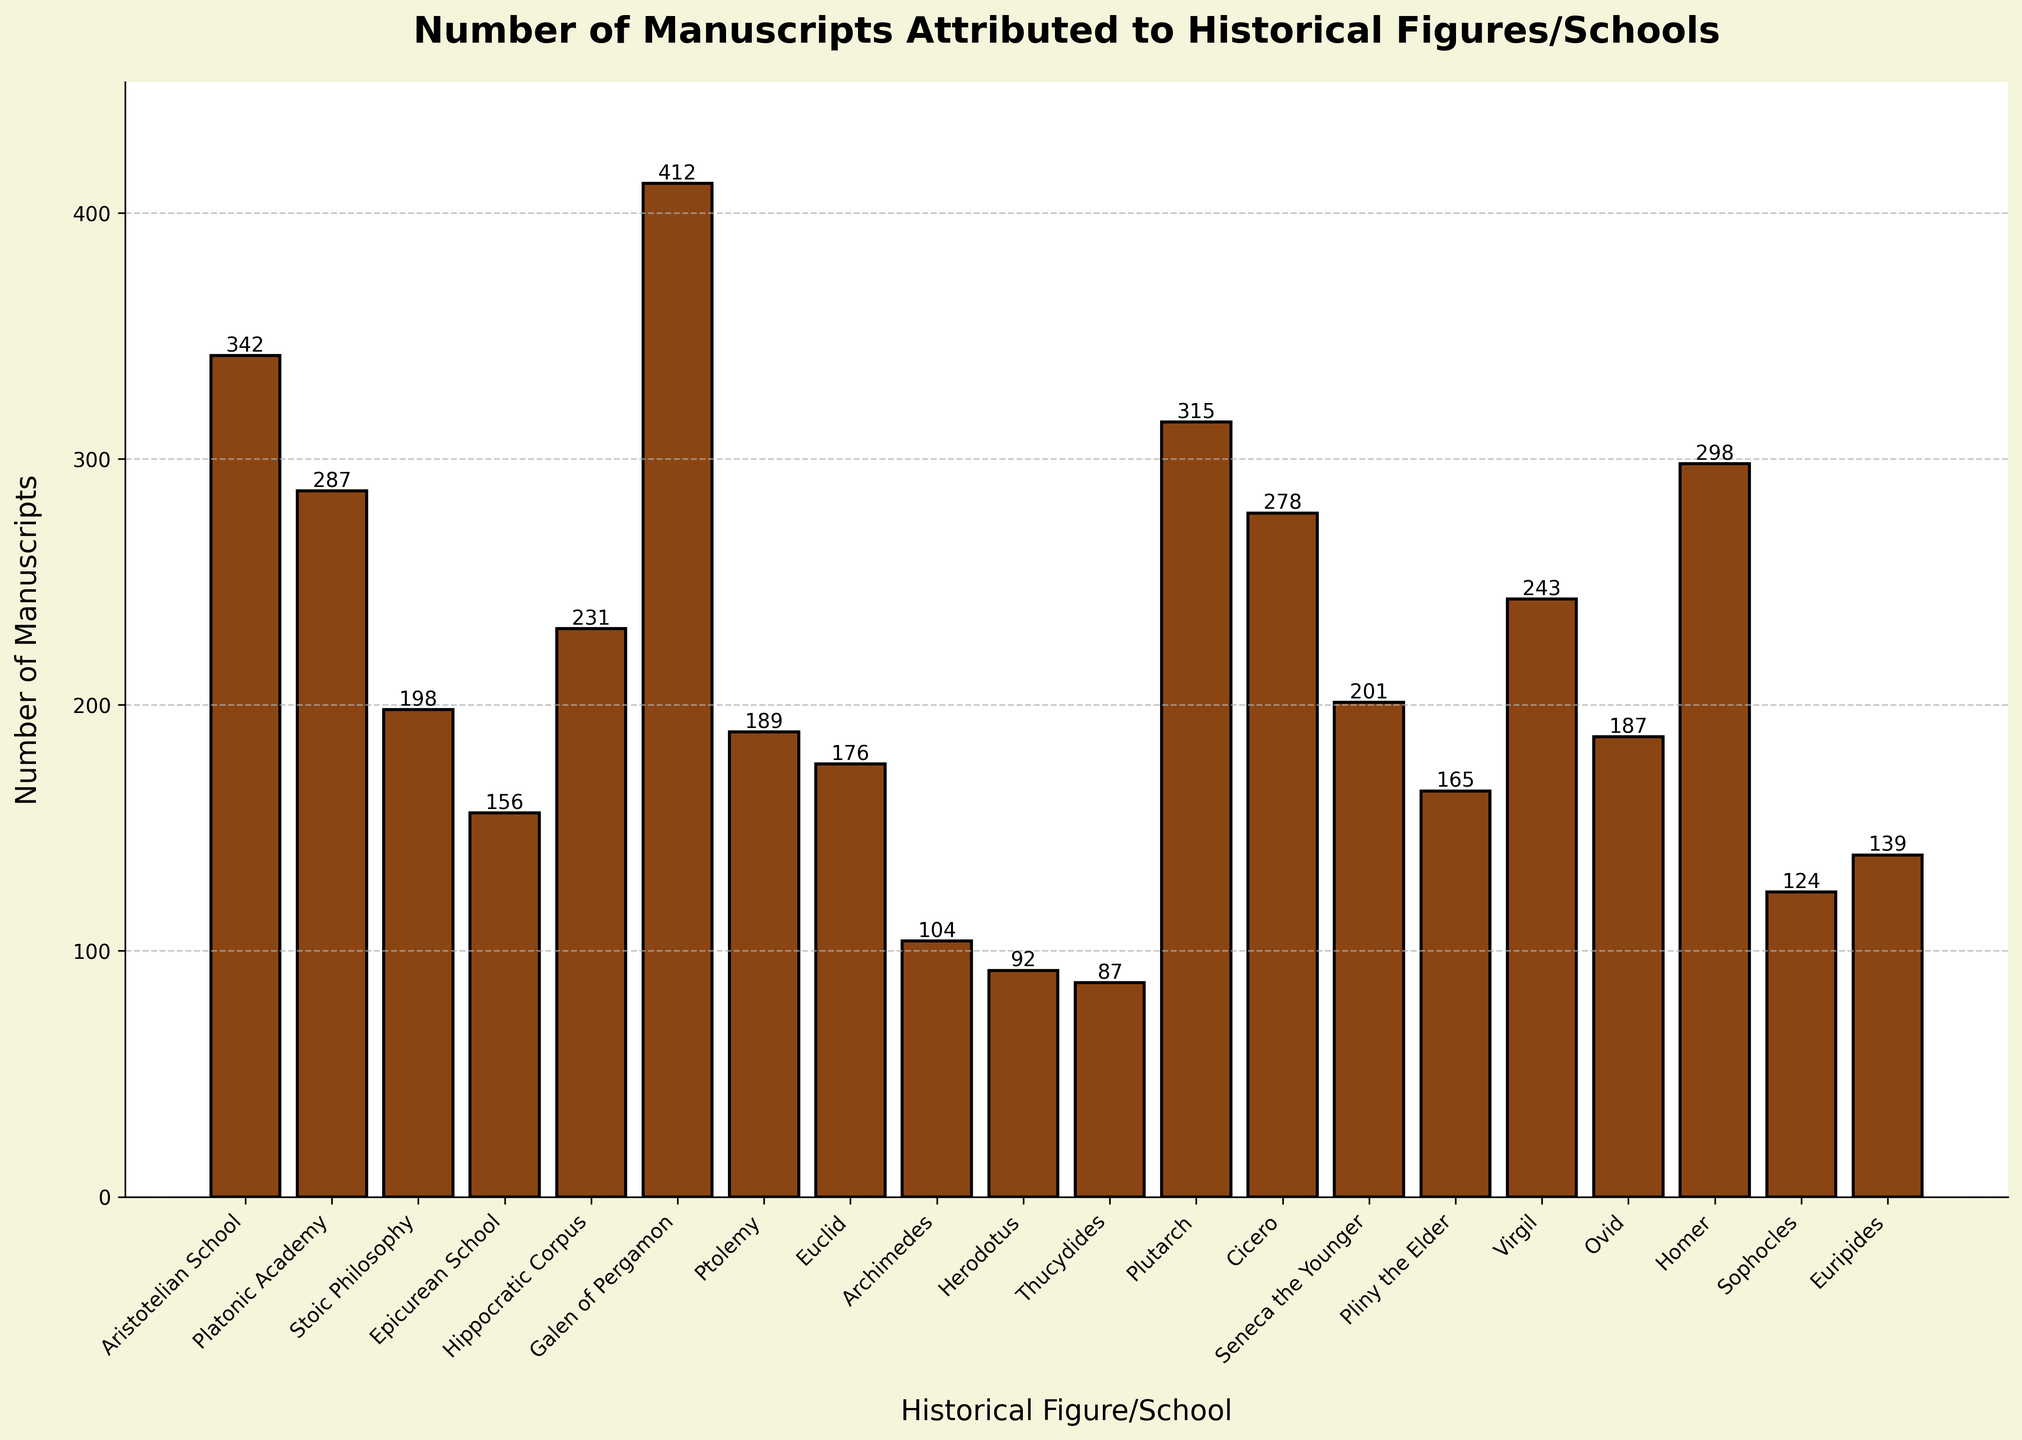Which historical figure/school has the highest number of attributed manuscripts? The bar corresponding to Galen of Pergamon is the tallest, indicating the highest number, followed by manually reading the label.
Answer: Galen of Pergamon How many more manuscripts are attributed to Galen of Pergamon than to the Aristotelian School? Subtract the number of manuscripts of the Aristotelian School (342) from Galen of Pergamon (412): 412 - 342 = 70.
Answer: 70 Compare the number of manuscripts attributed to Epicurean School and Seneca the Younger. Which has more? The height of the bar for Seneca the Younger (201) is greater than that of the Epicurean School (156).
Answer: Seneca the Younger What's the average number of manuscripts attributed to Plutarch, Cicero, and Virgil? Sum their manuscript counts (315 + 278 + 243) and divide by 3: (315 + 278 + 243) / 3 = 836 / 3 ≈ 278.67.
Answer: 278.67 What is the difference between the highest and the lowest number of manuscripts attributed? Subtract the count of the lowest (Thucydides, 87) from the highest (Galen of Pergamon, 412): 412 - 87 = 325.
Answer: 325 How many manuscripts are attributed to figures/schools that have fewer than 100 manuscripts each? For Herodotus (92), Thucydides (87), and Archimedes (104) observe that only Herodotus and Thucydides qualify. Summing their counts: 92 + 87 = 179.
Answer: 179 Which figure/school attributed with manuscripts has a number nearest to 200? Visually, the bars for Seneca the Younger (201) and Stoic Philosophy (198) are closest to 200; Seneca the Younger is closest.
Answer: Seneca the Younger What's the total number of manuscripts attributed to figures/schools beginning with the letter 'P' (Platonic Academy, Ptolemy, Plutarch, Pliny the Elder)? Sum their counts (287 + 189 + 315 + 165): 287 + 189 + 315 + 165 = 956.
Answer: 956 What visual attribute differentiates the Stoic Philosophy bar from the rest in the same height range? The Stoic Philosophy bar is colored the same (#8B4513) as the others but positioned distinctly among others like Seneca the Younger and Euclid.
Answer: Position among similar heights Which two figures/schools have the closest number of manuscripts, and what is their difference? Comparing figures: Ovid (187) and Ptolemy (189) have a difference of 2 manuscripts.
Answer: Ovid and Ptolemy; 2 